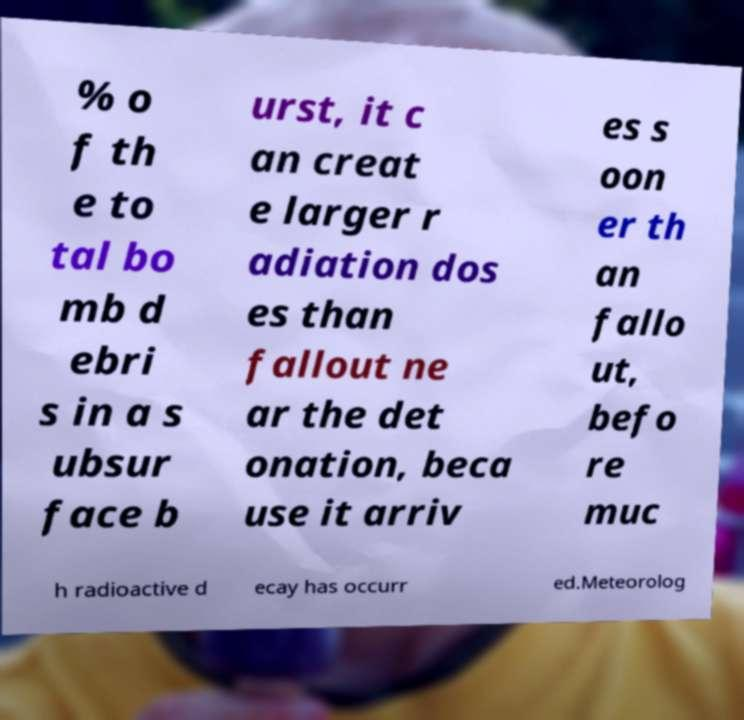Can you read and provide the text displayed in the image?This photo seems to have some interesting text. Can you extract and type it out for me? % o f th e to tal bo mb d ebri s in a s ubsur face b urst, it c an creat e larger r adiation dos es than fallout ne ar the det onation, beca use it arriv es s oon er th an fallo ut, befo re muc h radioactive d ecay has occurr ed.Meteorolog 